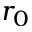<formula> <loc_0><loc_0><loc_500><loc_500>r _ { 0 }</formula> 